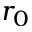<formula> <loc_0><loc_0><loc_500><loc_500>r _ { 0 }</formula> 